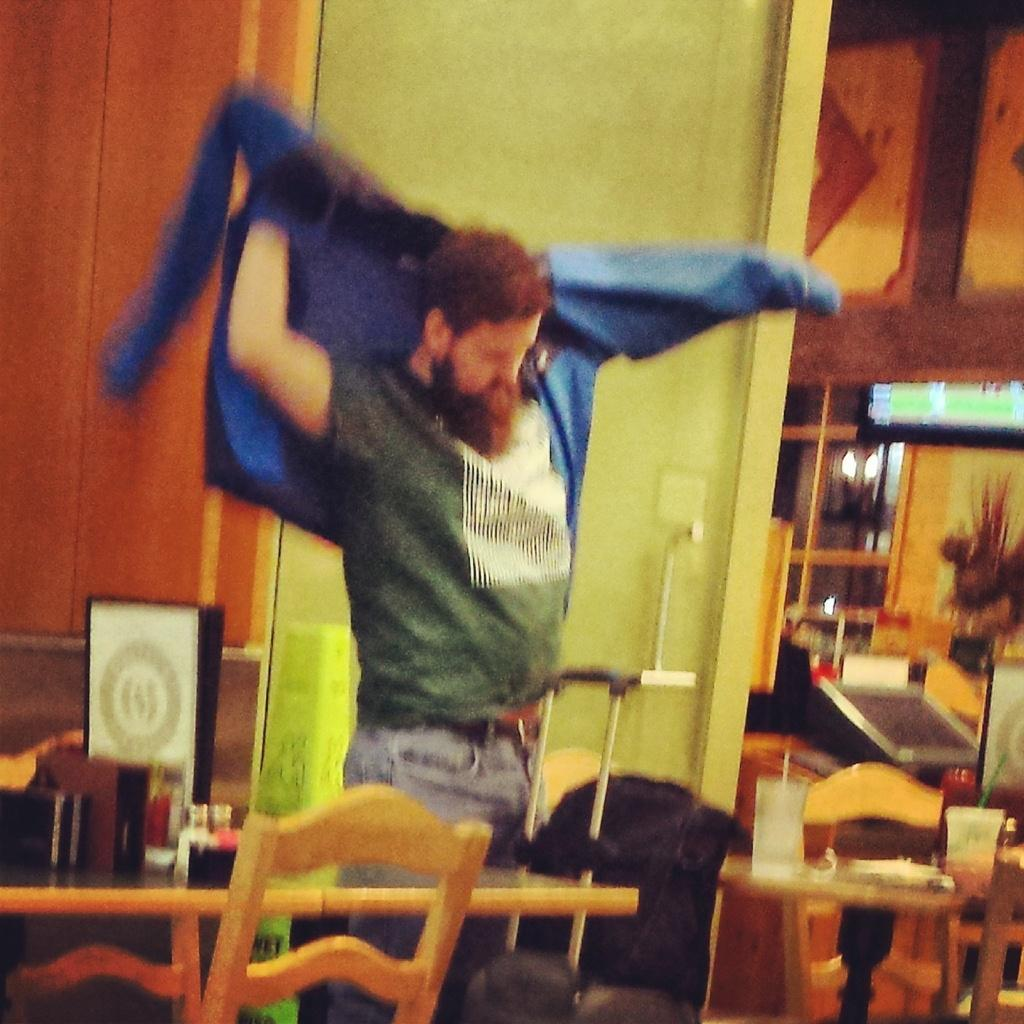What is the main subject of the image? There is a man in the image. What is the man doing in the image? The man is standing. What is the man wearing in the image? The man is wearing a blue jacket. What type of furniture can be seen in the image? There are chairs and tables in the image. What objects are on the table in the image? There are cups and glasses on the table. What electronic device is present in the image? There is a monitor in the image. What type of acoustics can be heard in the image? There is no information about sound or acoustics in the image, so it cannot be determined. How many legs are visible on the man in the image? The image only shows the man from the waist up, so no legs are visible. 